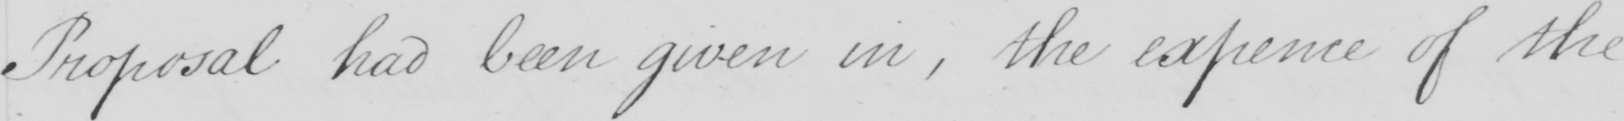Can you read and transcribe this handwriting? Proposal had been given in , the expence of the 